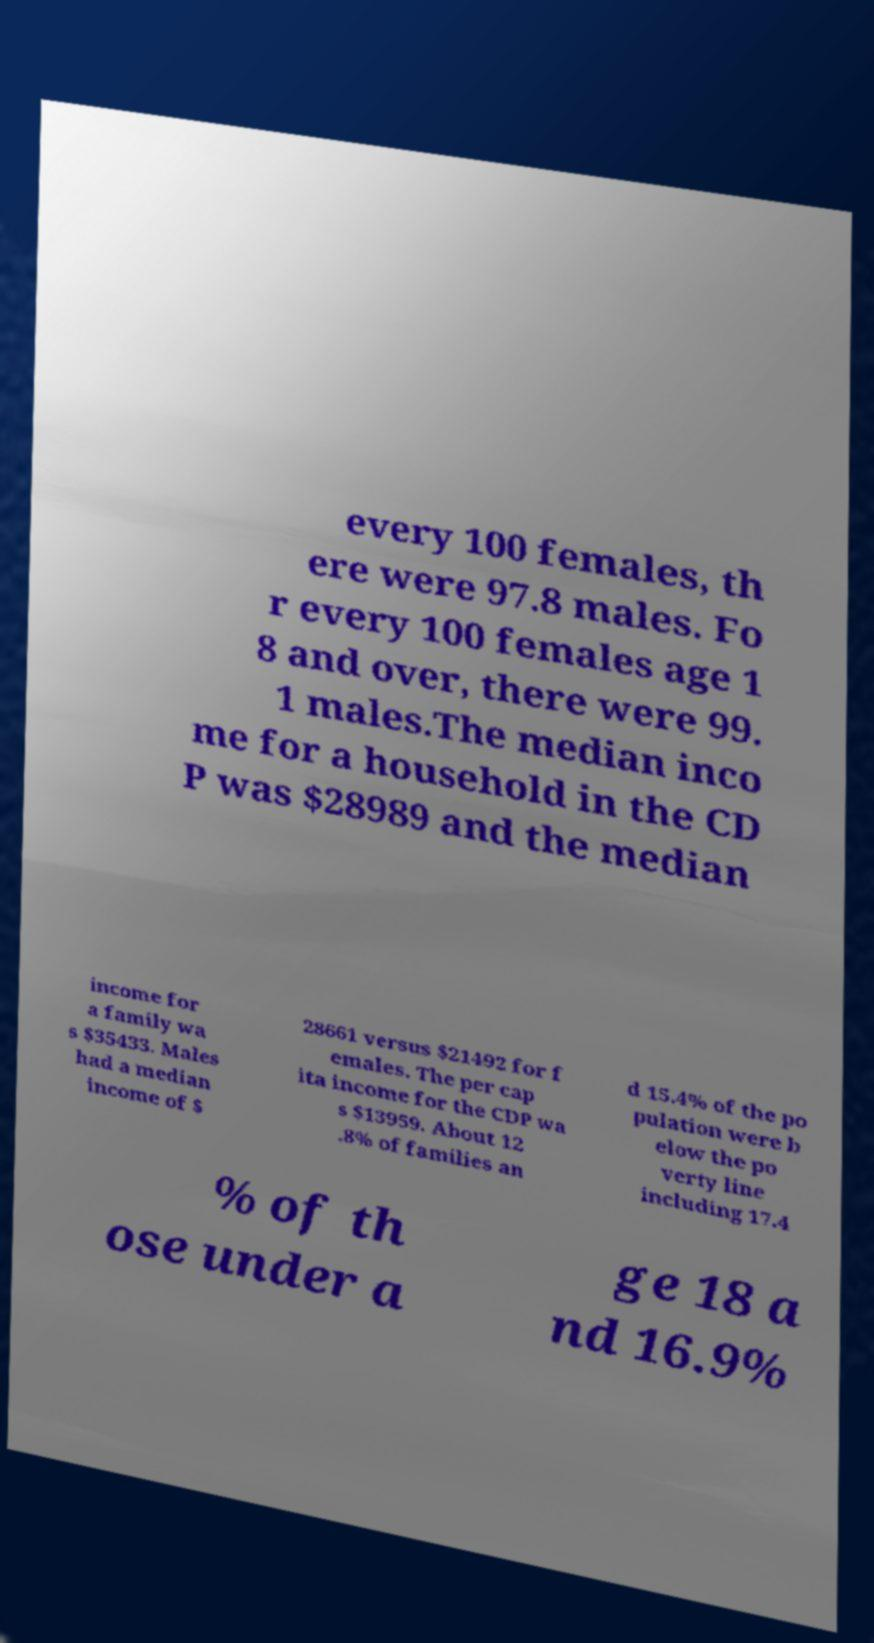What messages or text are displayed in this image? I need them in a readable, typed format. every 100 females, th ere were 97.8 males. Fo r every 100 females age 1 8 and over, there were 99. 1 males.The median inco me for a household in the CD P was $28989 and the median income for a family wa s $35433. Males had a median income of $ 28661 versus $21492 for f emales. The per cap ita income for the CDP wa s $13959. About 12 .8% of families an d 15.4% of the po pulation were b elow the po verty line including 17.4 % of th ose under a ge 18 a nd 16.9% 